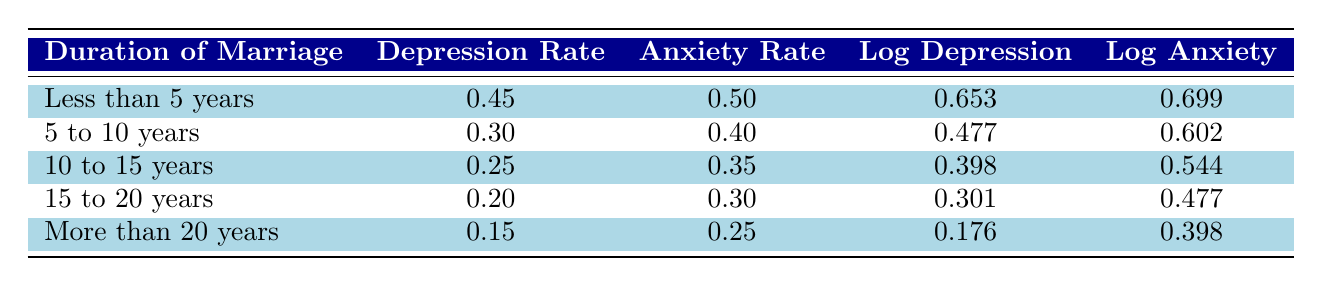What is the depression rate for individuals married for more than 20 years? The table shows the depression rate as 0.15 for individuals married for more than 20 years.
Answer: 0.15 How does the anxiety rate change from the duration of marriage "Less than 5 years" to "5 to 10 years"? The anxiety rate decreases from 0.50 (Less than 5 years) to 0.40 (5 to 10 years), indicating a reduction of 0.10.
Answer: Decreases by 0.10 What is the log depression value for marriages lasting between 10 to 15 years? The log depression value for that duration is given in the table as 0.398.
Answer: 0.398 Is the anxiety rate higher for those married for "Less than 5 years" compared to "More than 20 years"? Yes, the anxiety rate is 0.50 for "Less than 5 years" and 0.25 for "More than 20 years," showing it is higher for the former.
Answer: Yes What is the average depression rate for individuals whose marriages lasted between 5 to 10 years and 10 to 15 years? The depression rates for 5 to 10 years (0.30) and 10 to 15 years (0.25) are summed to get 0.55, and then averaged: 0.55/2 = 0.275.
Answer: 0.275 How does the log anxiety value for "15 to 20 years" compare to that for "More than 20 years"? The log anxiety value for "15 to 20 years" is 0.477 and for "More than 20 years" is 0.398. Comparing them, 0.477 is greater than 0.398.
Answer: Greater Which duration of marriage has the lowest depression rate? The table indicates that "More than 20 years" has the lowest depression rate of 0.15.
Answer: More than 20 years What is the total depression rate for all marriage durations listed in the table? The depression rates are summed together: 0.45 + 0.30 + 0.25 + 0.20 + 0.15 = 1.45. This is the total depression rate for all durations combined.
Answer: 1.45 